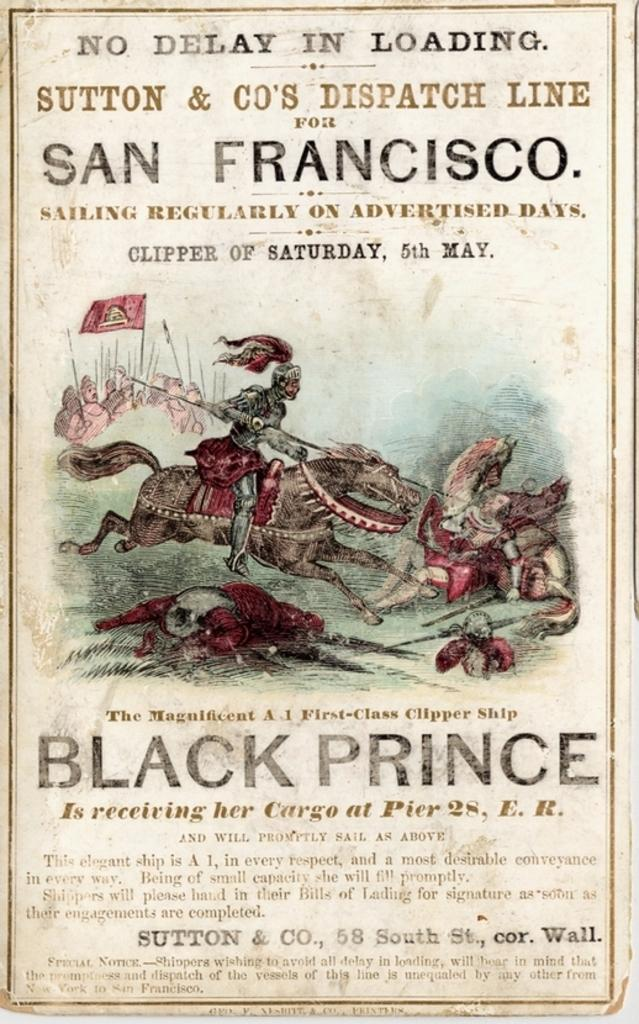<image>
Give a short and clear explanation of the subsequent image. An old advertisement for the Black Prince clipper ship in San Francisco. 